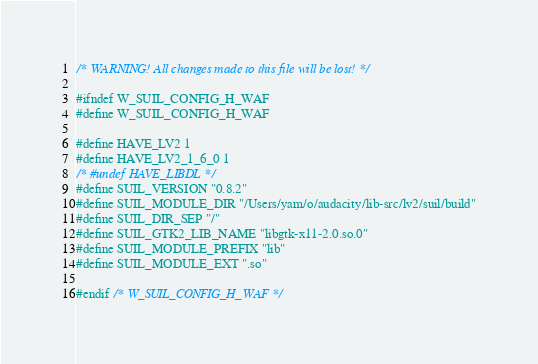Convert code to text. <code><loc_0><loc_0><loc_500><loc_500><_C_>/* WARNING! All changes made to this file will be lost! */

#ifndef W_SUIL_CONFIG_H_WAF
#define W_SUIL_CONFIG_H_WAF

#define HAVE_LV2 1
#define HAVE_LV2_1_6_0 1
/* #undef HAVE_LIBDL */
#define SUIL_VERSION "0.8.2"
#define SUIL_MODULE_DIR "/Users/yam/o/audacity/lib-src/lv2/suil/build"
#define SUIL_DIR_SEP "/"
#define SUIL_GTK2_LIB_NAME "libgtk-x11-2.0.so.0"
#define SUIL_MODULE_PREFIX "lib"
#define SUIL_MODULE_EXT ".so"

#endif /* W_SUIL_CONFIG_H_WAF */
</code> 